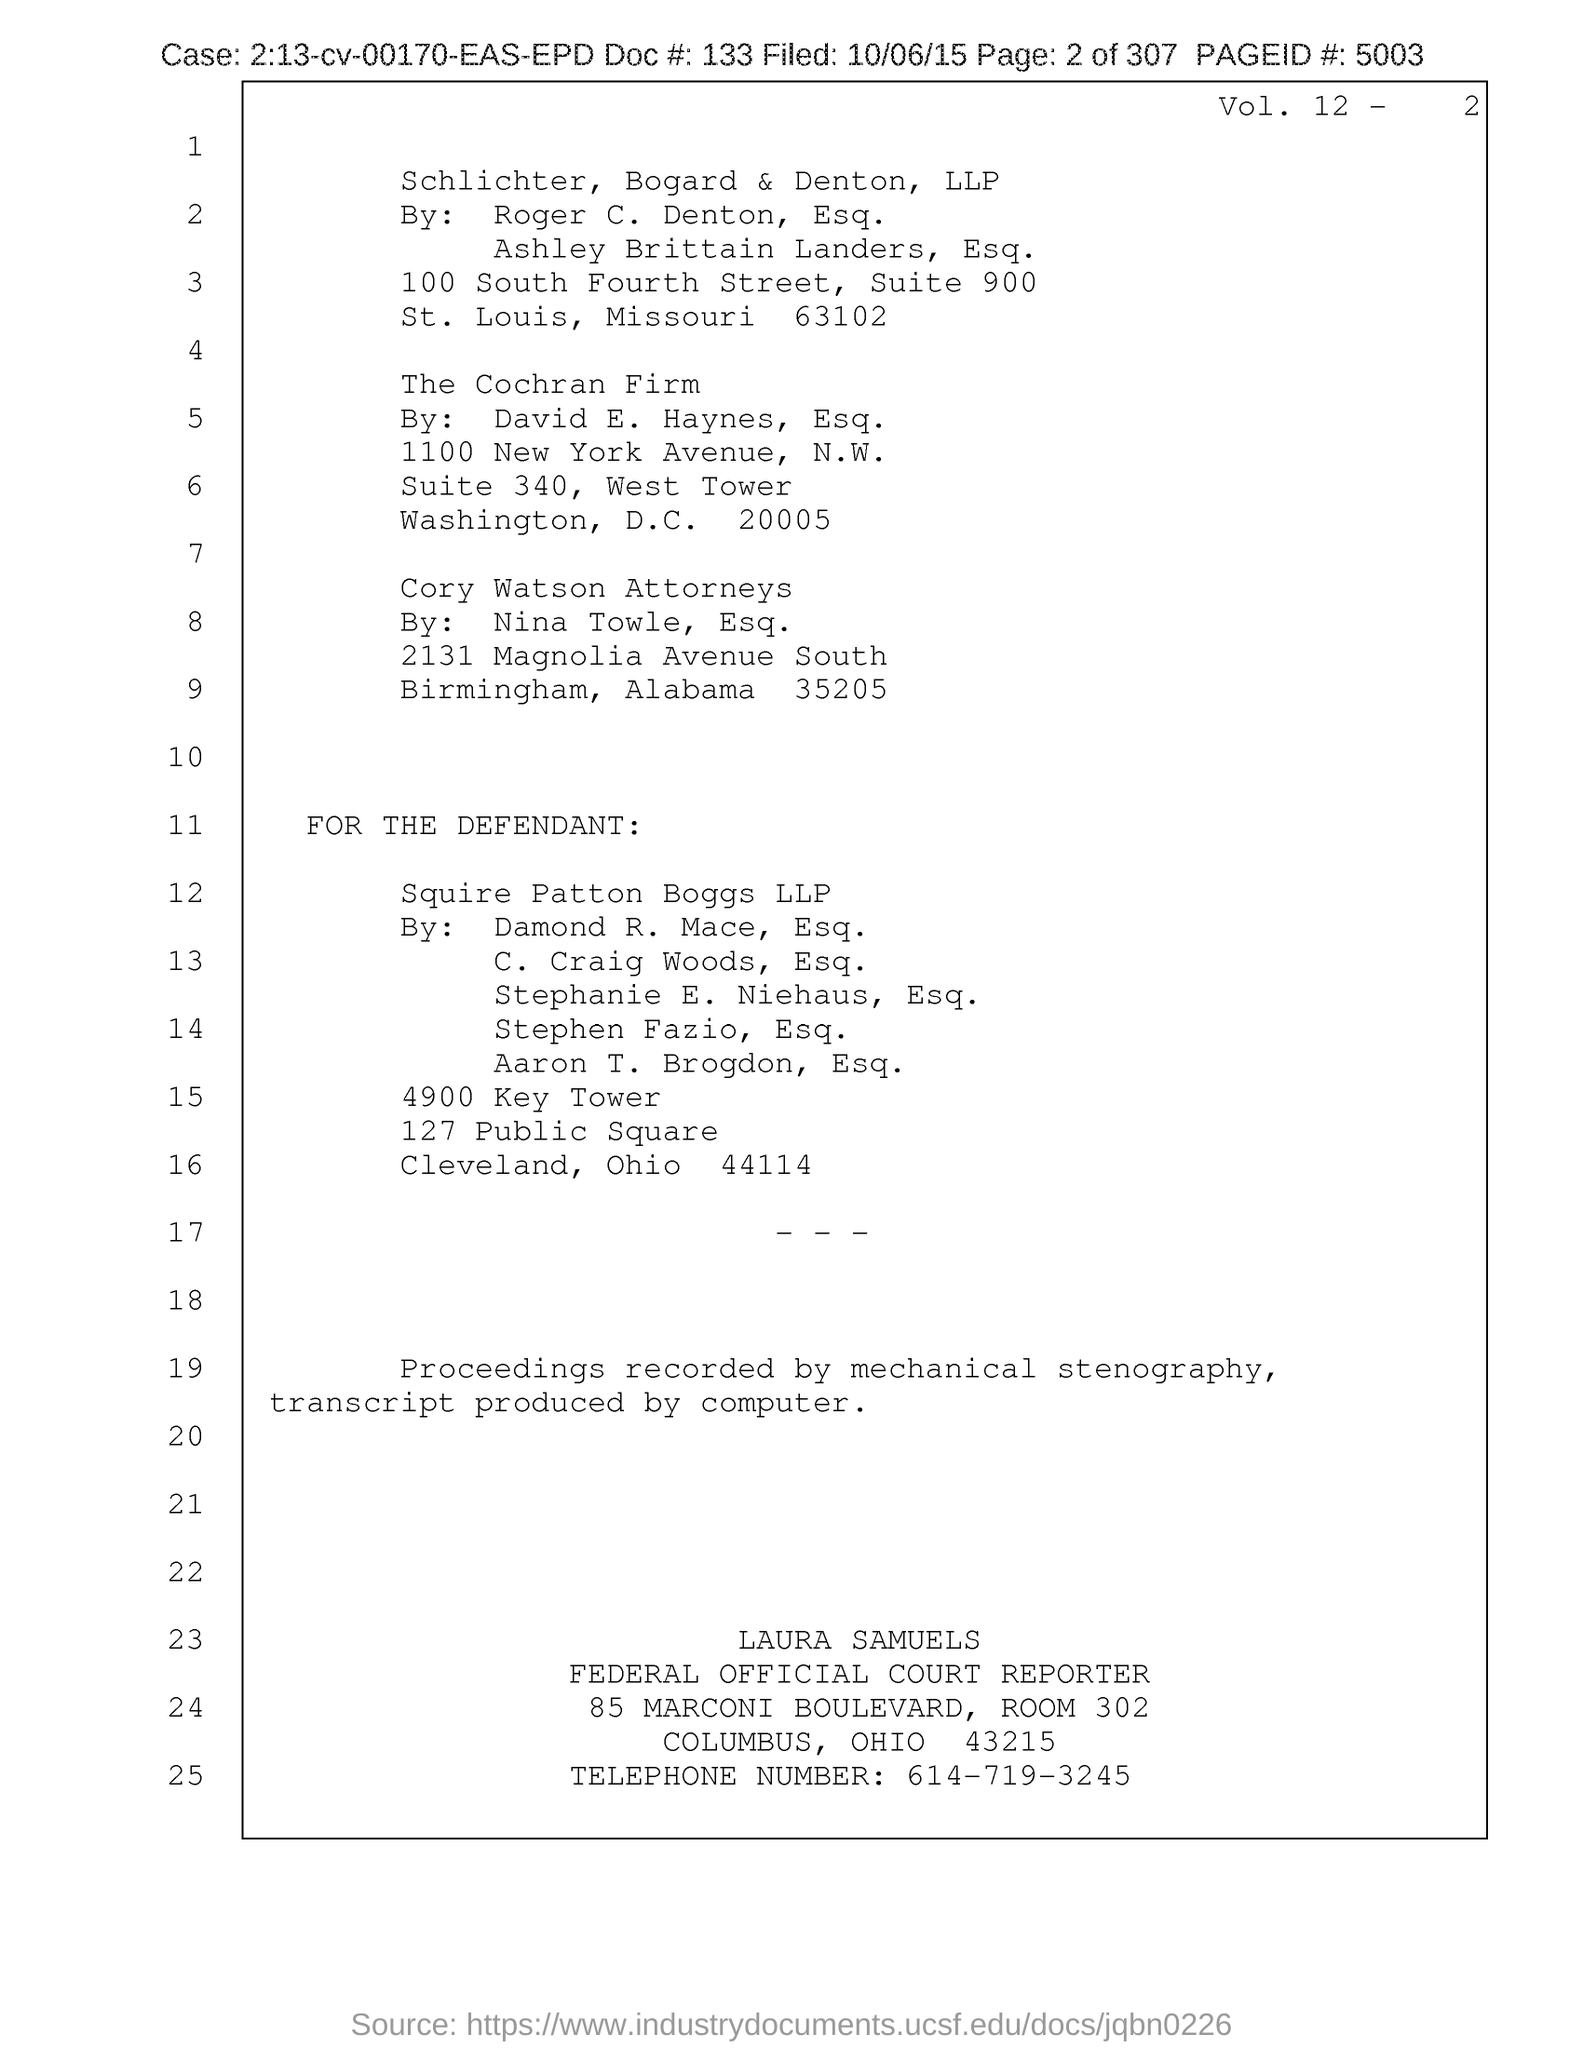Specify some key components in this picture. The telephone number is 614-719-3245. The page ID is 5003. 